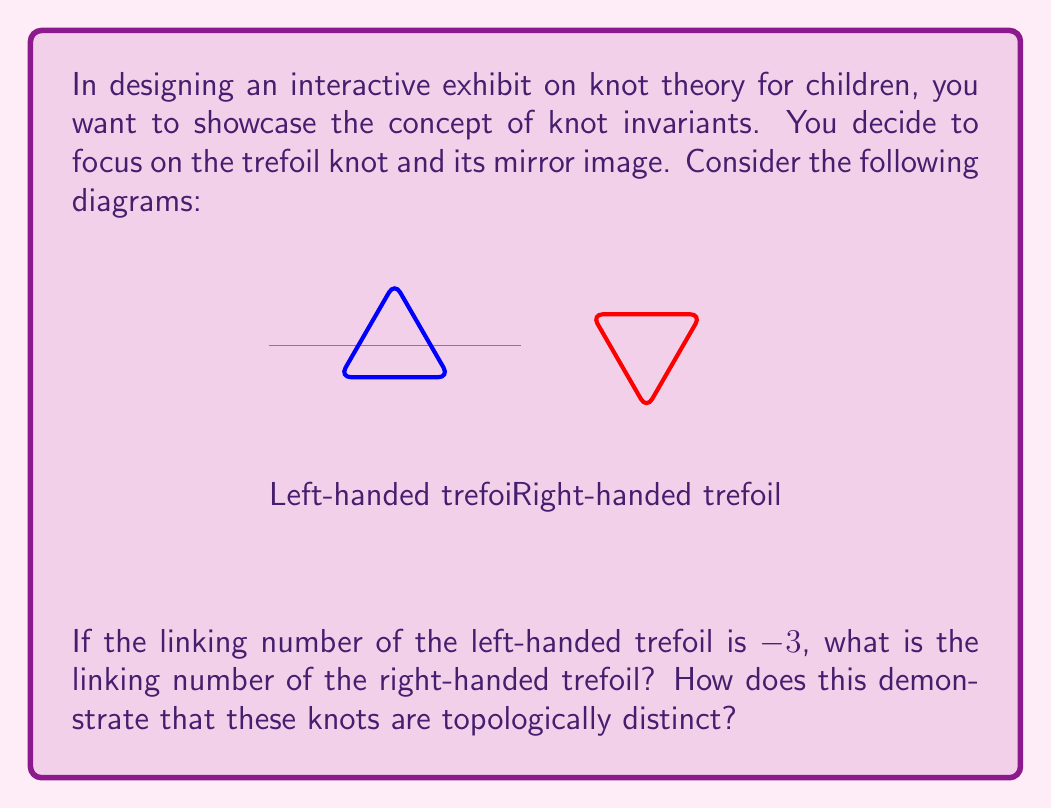Show me your answer to this math problem. Let's break this down step-by-step:

1) The linking number is a knot invariant that measures the number of times one part of the knot wraps around another part. It's calculated by summing the signs of crossings in a knot diagram.

2) For a trefoil knot, there are three crossings. In the left-handed trefoil, all crossings contribute -1 to the linking number, resulting in a total of -3.

3) The right-handed trefoil is the mirror image of the left-handed trefoil. When we take the mirror image of a knot, all crossings are reversed.

4) Therefore, in the right-handed trefoil, all crossings will contribute +1 to the linking number.

5) With three crossings, each contributing +1, the linking number of the right-handed trefoil is +3.

6) The linking number is an example of a knot invariant. Knot invariants are properties that remain unchanged under continuous deformations of the knot.

7) Since the left-handed and right-handed trefoils have different linking numbers (-3 and +3 respectively), this proves that they cannot be continuously deformed into one another.

8) In topological terms, this means that the left-handed and right-handed trefoils are topologically distinct, or not ambient isotopic.

This demonstration shows children that seemingly similar shapes can have fundamentally different properties, introducing them to the subtle and fascinating world of topology.
Answer: +3; Different linking numbers prove the knots are topologically distinct. 